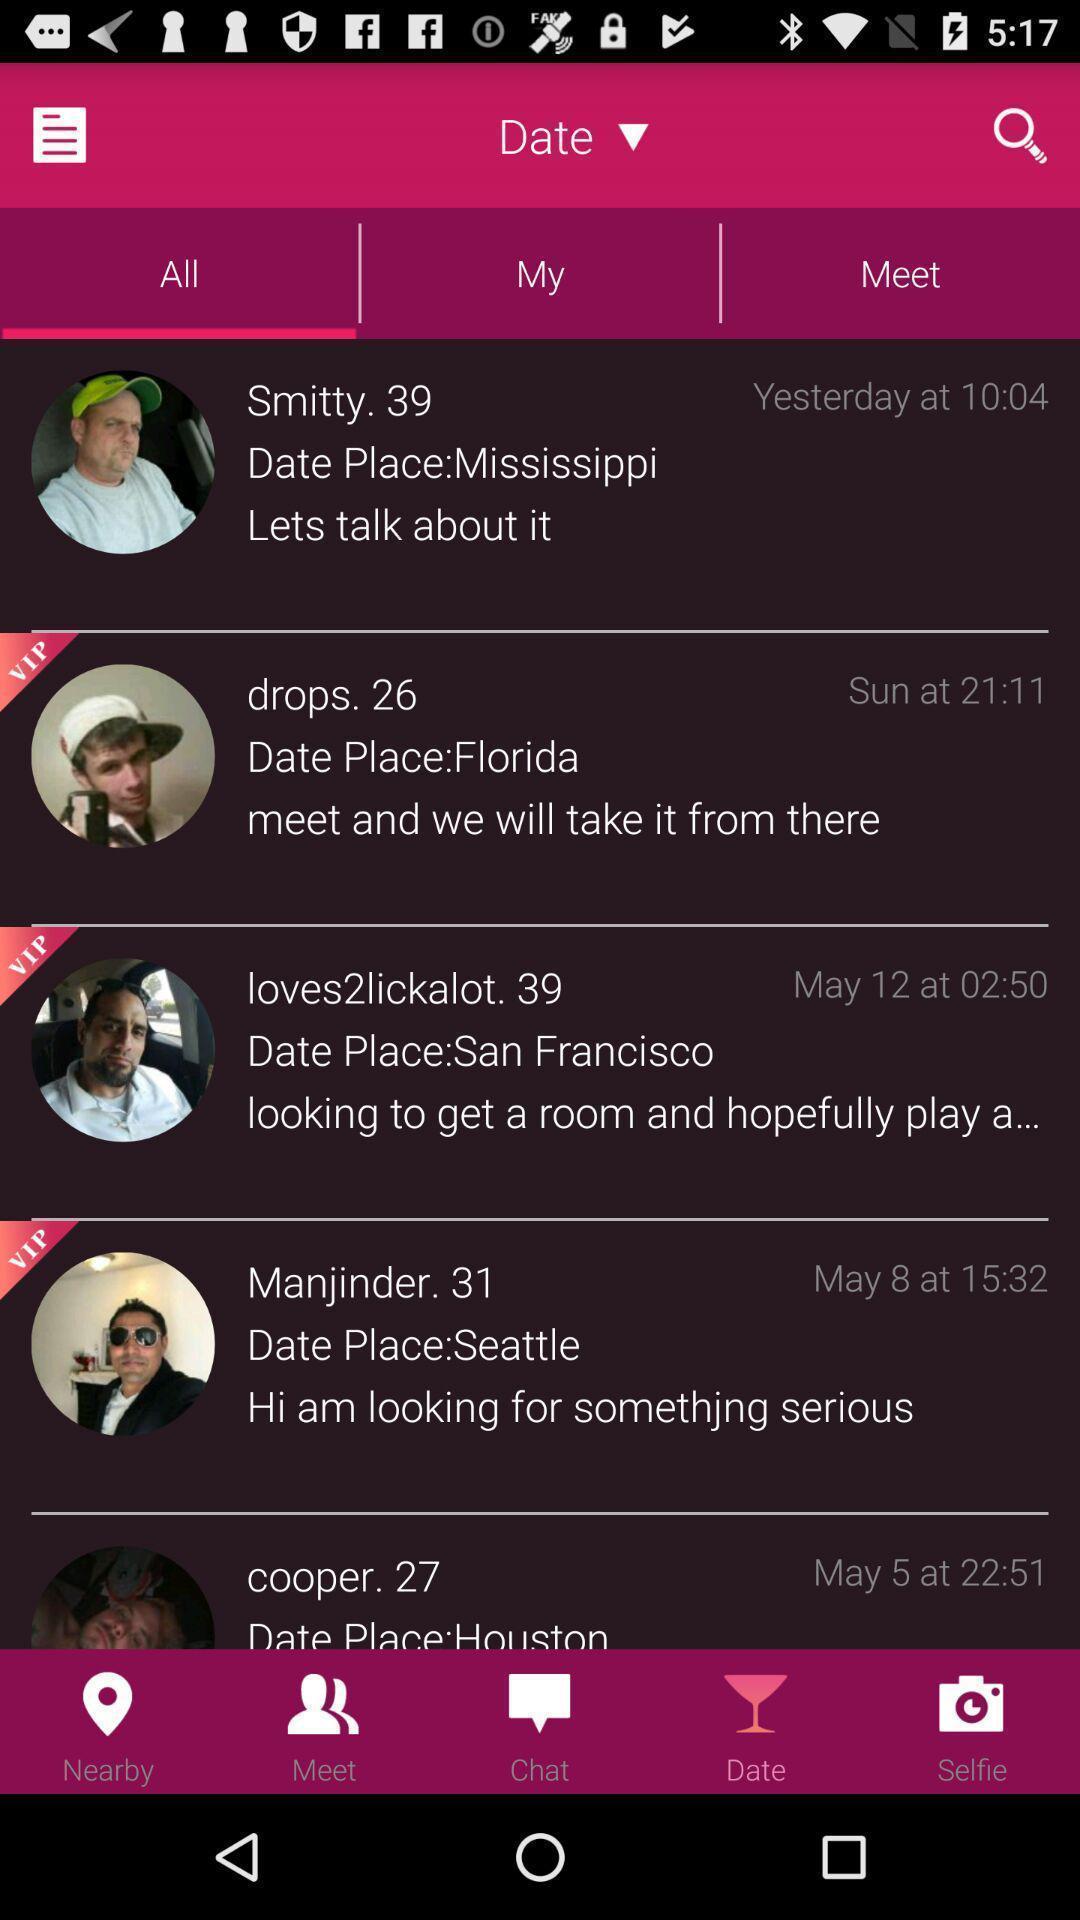Explain the elements present in this screenshot. Page displaying with few profiles in dating application. 